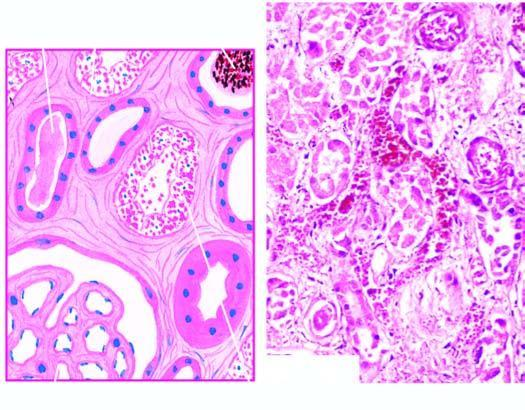what is there along the nephron involving proximal convoluted tubule as well as distal convoluted tubule dct?
Answer the question using a single word or phrase. Focal necrosis 